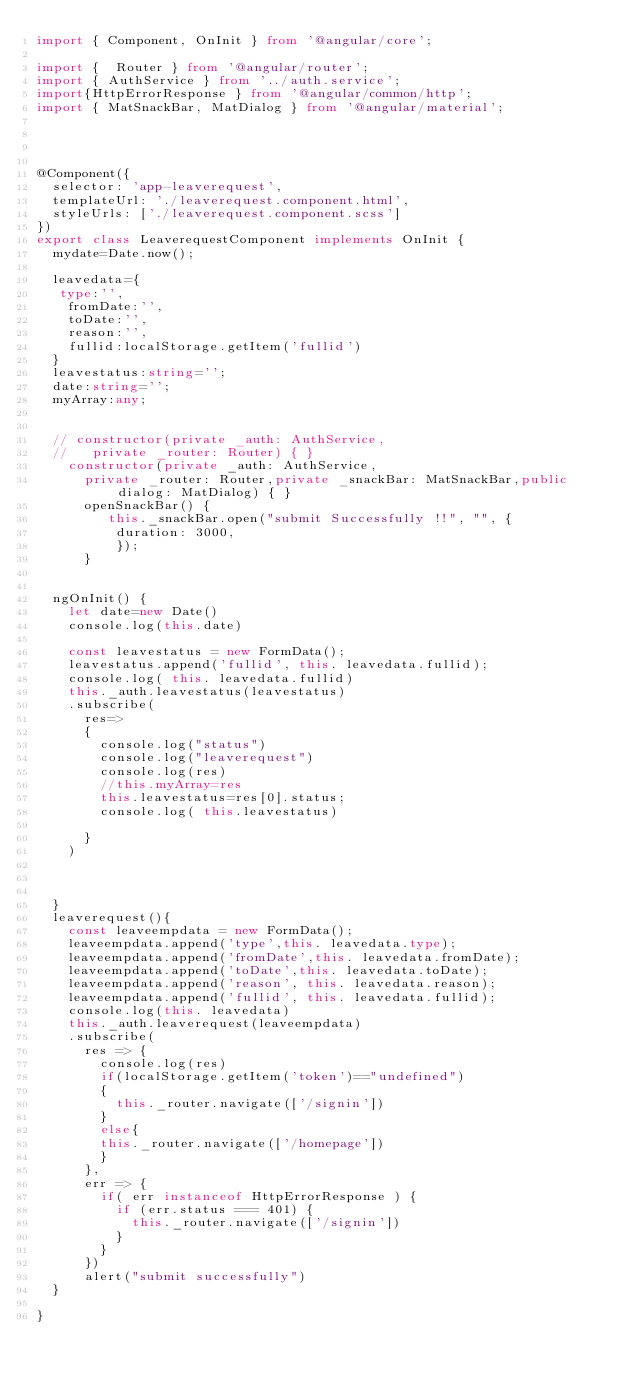<code> <loc_0><loc_0><loc_500><loc_500><_TypeScript_>import { Component, OnInit } from '@angular/core';

import {  Router } from '@angular/router';
import { AuthService } from '../auth.service';
import{HttpErrorResponse } from '@angular/common/http';
import { MatSnackBar, MatDialog } from '@angular/material';




@Component({
  selector: 'app-leaverequest',
  templateUrl: './leaverequest.component.html',
  styleUrls: ['./leaverequest.component.scss']
})
export class LeaverequestComponent implements OnInit {
  mydate=Date.now();

  leavedata={
   type:'',
    fromDate:'',
    toDate:'',
    reason:'',
    fullid:localStorage.getItem('fullid')
  }
  leavestatus:string='';
  date:string='';
  myArray:any;
  

  // constructor(private _auth: AuthService,
  //   private _router: Router) { }
    constructor(private _auth: AuthService,
      private _router: Router,private _snackBar: MatSnackBar,public dialog: MatDialog) { }
      openSnackBar() {      
         this._snackBar.open("submit Successfully !!", "", { 
          duration: 3000,
          });                      
      }


  ngOnInit() {
    let date=new Date()
    console.log(this.date)
   
    const leavestatus = new FormData();
    leavestatus.append('fullid', this. leavedata.fullid);
    console.log( this. leavedata.fullid)
    this._auth.leavestatus(leavestatus)
    .subscribe(
      res=>
      {
        console.log("status")
        console.log("leaverequest")
        console.log(res)
        //this.myArray=res
        this.leavestatus=res[0].status;
        console.log( this.leavestatus)

      }
    )



  }
  leaverequest(){
    const leaveempdata = new FormData();
    leaveempdata.append('type',this. leavedata.type);
    leaveempdata.append('fromDate',this. leavedata.fromDate);
    leaveempdata.append('toDate',this. leavedata.toDate);
    leaveempdata.append('reason', this. leavedata.reason);
    leaveempdata.append('fullid', this. leavedata.fullid);
    console.log(this. leavedata)
    this._auth.leaverequest(leaveempdata)
    .subscribe(
      res => {
        console.log(res)
        if(localStorage.getItem('token')=="undefined")
        {
          this._router.navigate(['/signin'])
        }
        else{
        this._router.navigate(['/homepage'])
        }
      },
      err => {
        if( err instanceof HttpErrorResponse ) {
          if (err.status === 401) {
            this._router.navigate(['/signin'])
          }
        }
      })
      alert("submit successfully")
  }

}
</code> 